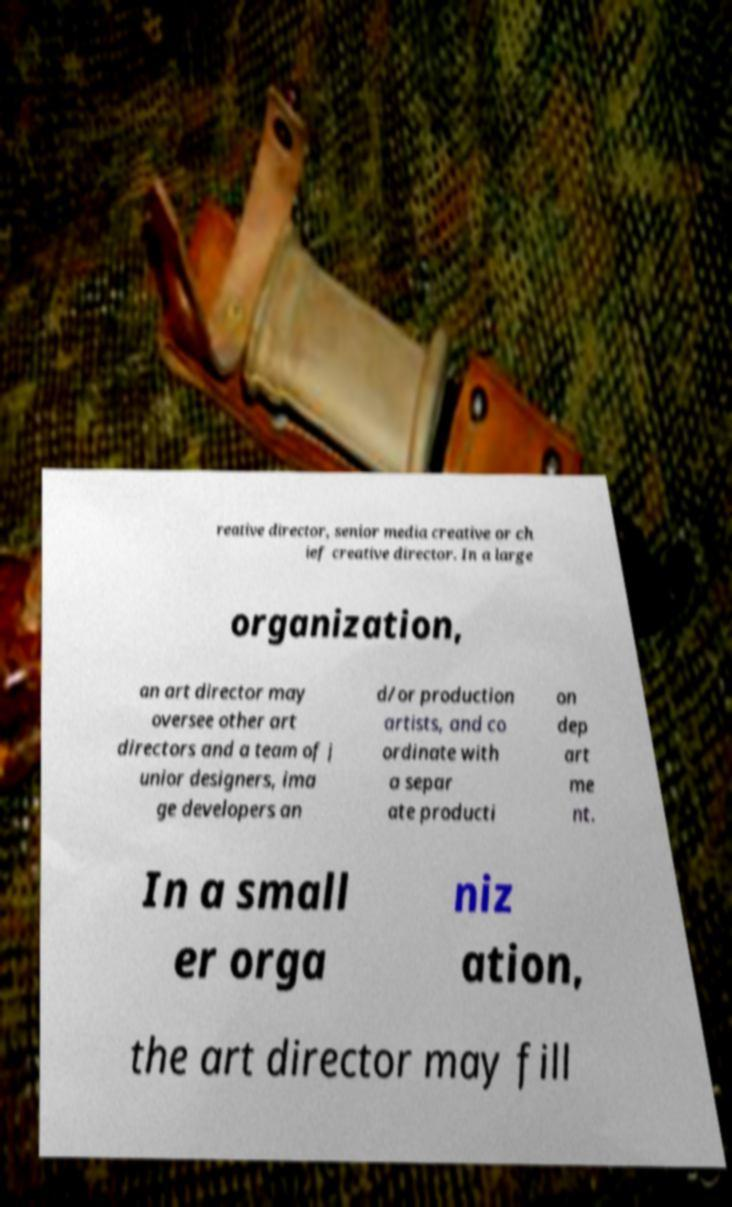Can you accurately transcribe the text from the provided image for me? reative director, senior media creative or ch ief creative director. In a large organization, an art director may oversee other art directors and a team of j unior designers, ima ge developers an d/or production artists, and co ordinate with a separ ate producti on dep art me nt. In a small er orga niz ation, the art director may fill 